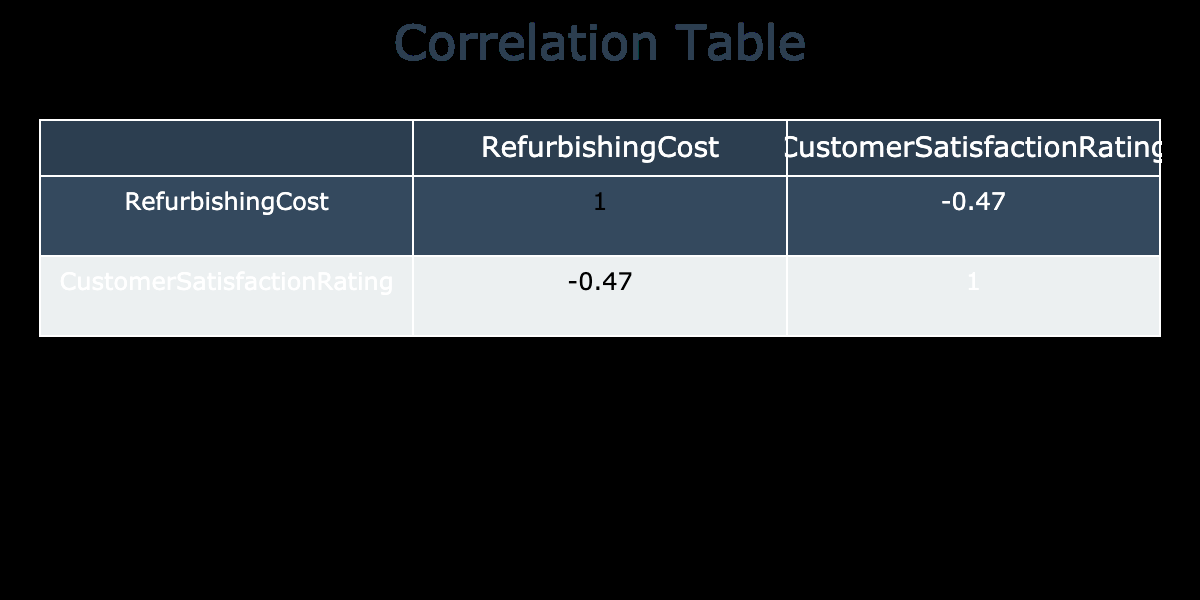What is the correlation coefficient between refurbishing cost and customer satisfaction rating? The correlation matrix shows that the value for the correlation between refurbishing cost and customer satisfaction rating is -0.17.
Answer: -0.17 Which prop type has the highest customer satisfaction rating? Looking at the customer satisfaction rating column, the Wooden Toy Train has the highest rating at 4.9.
Answer: Wooden Toy Train Is there a prop type that has a refurbishing cost of 200? Yes, the Retro Telephone has a refurbishing cost of 200.
Answer: Yes What is the average refurbishing cost of props with customer satisfaction ratings above 4.5? To find the average refurbishing cost of props rated above 4.5, we first identify the props: Victorian Lamp (350), Antique Typewriter (500), Gramophone (600), and Enamel Sign (280). Then we calculate the total: 350 + 500 + 600 + 280 = 1730. There are 4 props, so the average is 1730 / 4 = 432.5.
Answer: 432.5 How many prop types have a customer satisfaction rating below 4.5? Examining the customer satisfaction ratings, there are three props below 4.5: Old Cinema Projector (4.2), Leather Briefcase (4.1), and Metal Wall Clock (4.3).
Answer: 3 